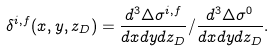<formula> <loc_0><loc_0><loc_500><loc_500>\delta ^ { i , f } ( x , y , z _ { D } ) = \frac { d ^ { 3 } \Delta \sigma ^ { i , f } } { d x d y d z _ { D } } / \frac { d ^ { 3 } \Delta \sigma ^ { 0 } } { d x d y d z _ { D } } .</formula> 